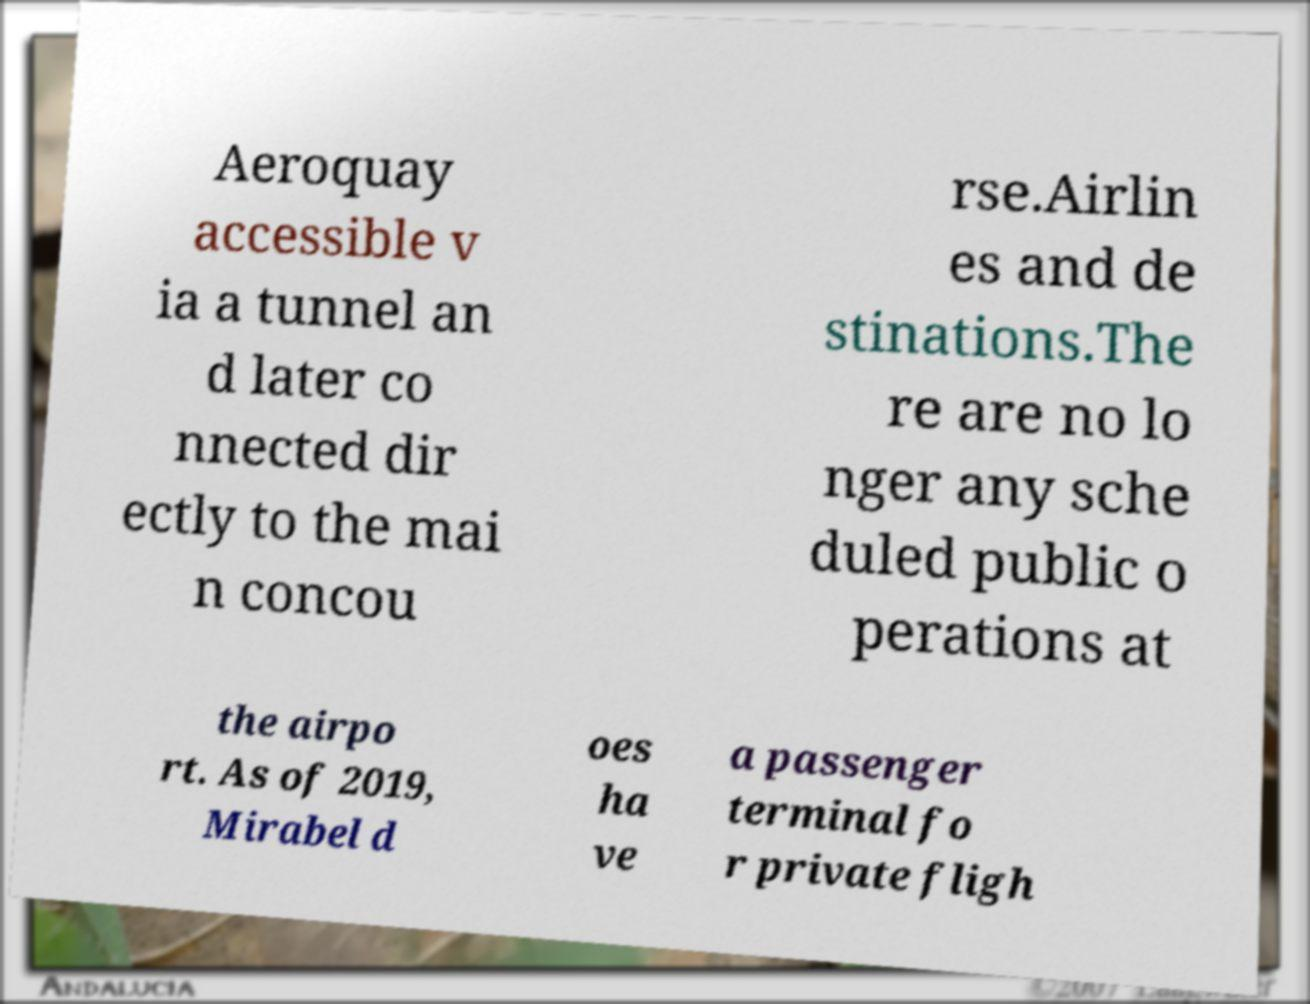Can you accurately transcribe the text from the provided image for me? Aeroquay accessible v ia a tunnel an d later co nnected dir ectly to the mai n concou rse.Airlin es and de stinations.The re are no lo nger any sche duled public o perations at the airpo rt. As of 2019, Mirabel d oes ha ve a passenger terminal fo r private fligh 